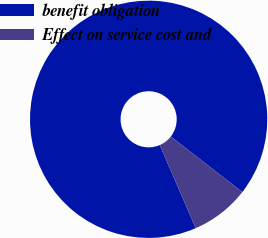Convert chart to OTSL. <chart><loc_0><loc_0><loc_500><loc_500><pie_chart><fcel>benefit obligation<fcel>Effect on service cost and<nl><fcel>92.0%<fcel>8.0%<nl></chart> 